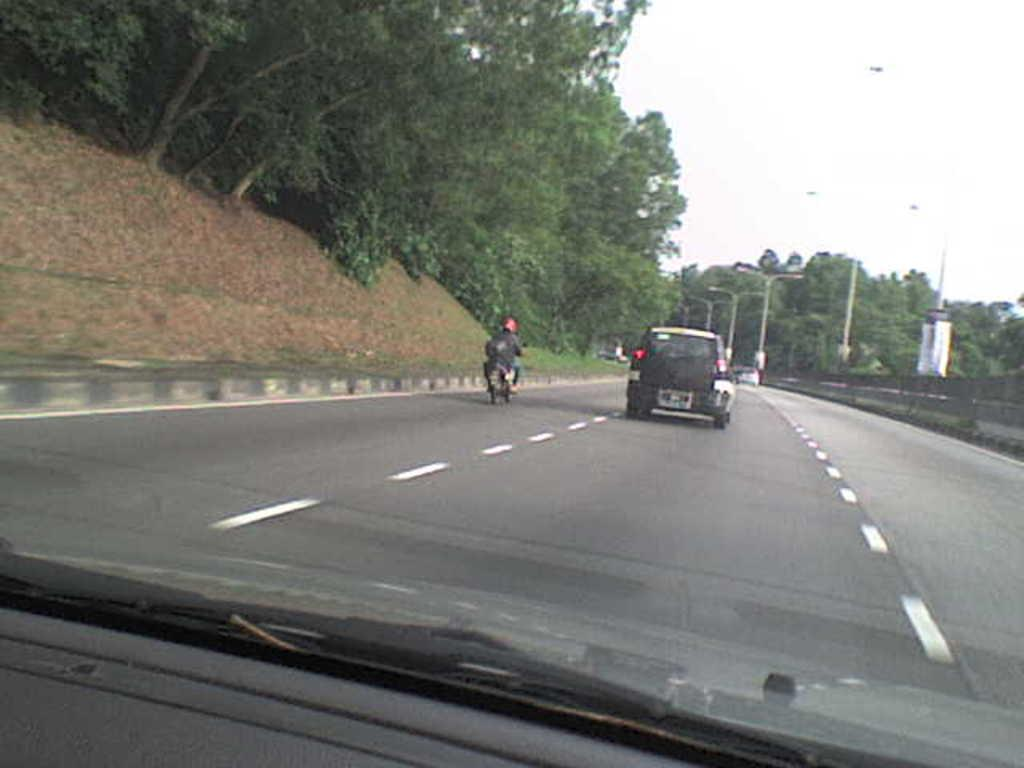What type of vegetation can be seen in the image? There are trees in the image. What type of artificial light source is present in the image? There are streetlamps in the image. What mode of transportation can be seen in the image? There is a car in the image. What is the man in the image doing? The man is riding a motorcycle in the image. What is visible at the top of the image? The sky is visible at the top of the image. Can you tell me how many seeds the man is holding while riding the motorcycle? There is no mention of seeds in the image, and the man is not holding any seeds while riding the motorcycle. What type of animal is sitting on the car in the image? There is no animal, such as a monkey, present on the car in the image. 